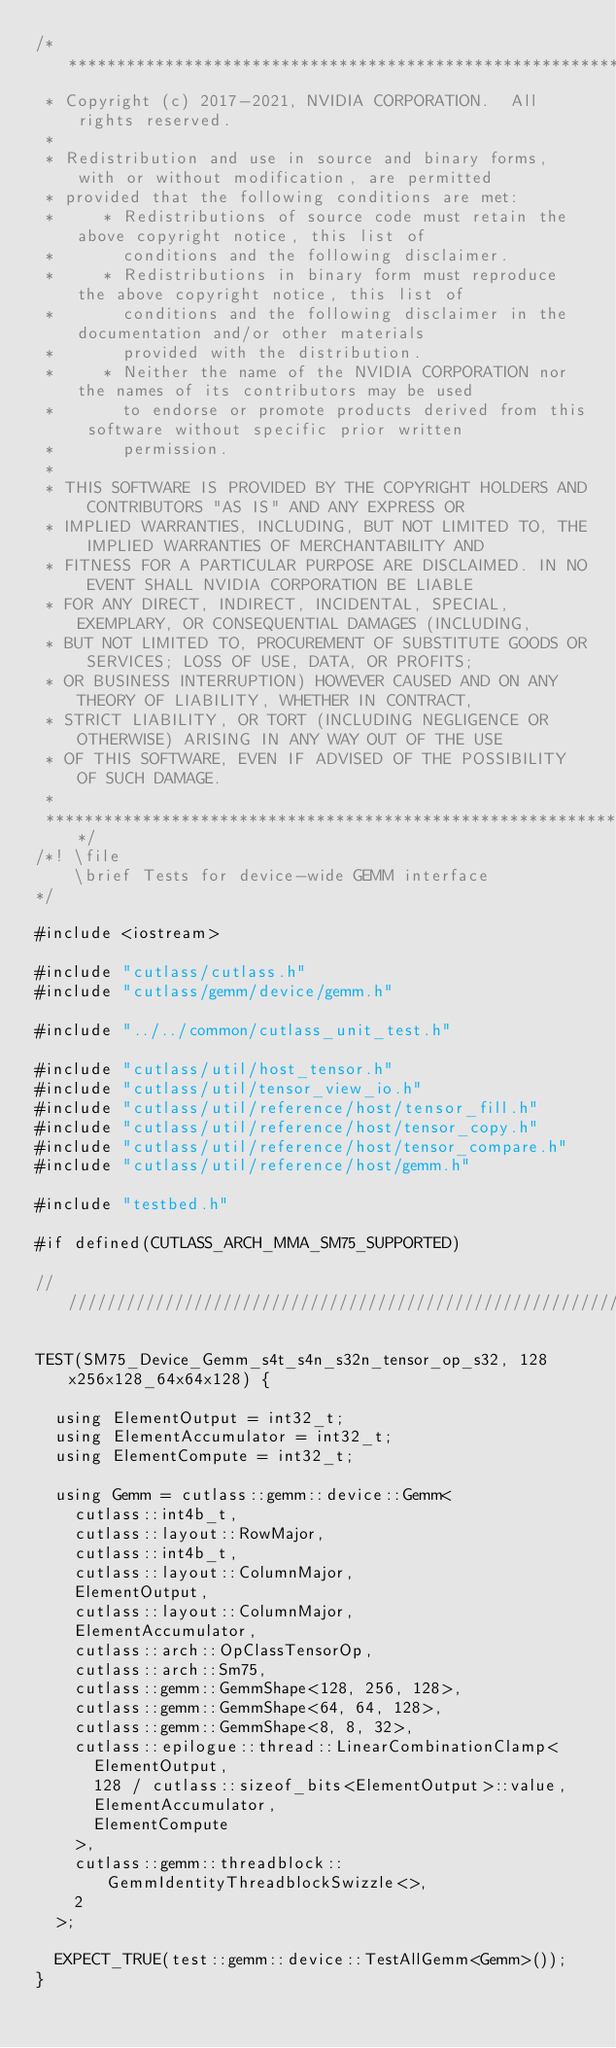Convert code to text. <code><loc_0><loc_0><loc_500><loc_500><_Cuda_>/***************************************************************************************************
 * Copyright (c) 2017-2021, NVIDIA CORPORATION.  All rights reserved.
 *
 * Redistribution and use in source and binary forms, with or without modification, are permitted
 * provided that the following conditions are met:
 *     * Redistributions of source code must retain the above copyright notice, this list of
 *       conditions and the following disclaimer.
 *     * Redistributions in binary form must reproduce the above copyright notice, this list of
 *       conditions and the following disclaimer in the documentation and/or other materials
 *       provided with the distribution.
 *     * Neither the name of the NVIDIA CORPORATION nor the names of its contributors may be used
 *       to endorse or promote products derived from this software without specific prior written
 *       permission.
 *
 * THIS SOFTWARE IS PROVIDED BY THE COPYRIGHT HOLDERS AND CONTRIBUTORS "AS IS" AND ANY EXPRESS OR
 * IMPLIED WARRANTIES, INCLUDING, BUT NOT LIMITED TO, THE IMPLIED WARRANTIES OF MERCHANTABILITY AND
 * FITNESS FOR A PARTICULAR PURPOSE ARE DISCLAIMED. IN NO EVENT SHALL NVIDIA CORPORATION BE LIABLE
 * FOR ANY DIRECT, INDIRECT, INCIDENTAL, SPECIAL, EXEMPLARY, OR CONSEQUENTIAL DAMAGES (INCLUDING,
 * BUT NOT LIMITED TO, PROCUREMENT OF SUBSTITUTE GOODS OR SERVICES; LOSS OF USE, DATA, OR PROFITS;
 * OR BUSINESS INTERRUPTION) HOWEVER CAUSED AND ON ANY THEORY OF LIABILITY, WHETHER IN CONTRACT,
 * STRICT LIABILITY, OR TORT (INCLUDING NEGLIGENCE OR OTHERWISE) ARISING IN ANY WAY OUT OF THE USE
 * OF THIS SOFTWARE, EVEN IF ADVISED OF THE POSSIBILITY OF SUCH DAMAGE.
 *
 **************************************************************************************************/
/*! \file
    \brief Tests for device-wide GEMM interface
*/

#include <iostream>

#include "cutlass/cutlass.h"
#include "cutlass/gemm/device/gemm.h"

#include "../../common/cutlass_unit_test.h"

#include "cutlass/util/host_tensor.h"
#include "cutlass/util/tensor_view_io.h"
#include "cutlass/util/reference/host/tensor_fill.h"
#include "cutlass/util/reference/host/tensor_copy.h"
#include "cutlass/util/reference/host/tensor_compare.h"
#include "cutlass/util/reference/host/gemm.h"

#include "testbed.h"

#if defined(CUTLASS_ARCH_MMA_SM75_SUPPORTED)

/////////////////////////////////////////////////////////////////////////////////////////////////

TEST(SM75_Device_Gemm_s4t_s4n_s32n_tensor_op_s32, 128x256x128_64x64x128) {

  using ElementOutput = int32_t;
  using ElementAccumulator = int32_t;
  using ElementCompute = int32_t;

  using Gemm = cutlass::gemm::device::Gemm<
    cutlass::int4b_t,
    cutlass::layout::RowMajor,
    cutlass::int4b_t,
    cutlass::layout::ColumnMajor,
    ElementOutput,
    cutlass::layout::ColumnMajor,
    ElementAccumulator,
    cutlass::arch::OpClassTensorOp,
    cutlass::arch::Sm75,
    cutlass::gemm::GemmShape<128, 256, 128>,
    cutlass::gemm::GemmShape<64, 64, 128>,
    cutlass::gemm::GemmShape<8, 8, 32>,
    cutlass::epilogue::thread::LinearCombinationClamp<
      ElementOutput,
      128 / cutlass::sizeof_bits<ElementOutput>::value,
      ElementAccumulator,
      ElementCompute
    >,
    cutlass::gemm::threadblock::GemmIdentityThreadblockSwizzle<>,
    2
  >;

  EXPECT_TRUE(test::gemm::device::TestAllGemm<Gemm>());
}
</code> 